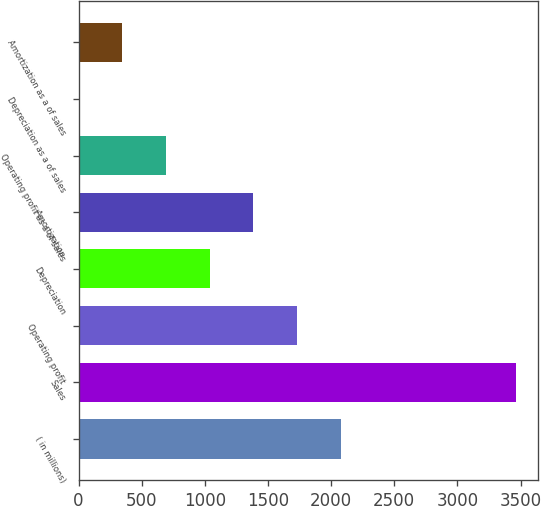<chart> <loc_0><loc_0><loc_500><loc_500><bar_chart><fcel>( in millions)<fcel>Sales<fcel>Operating profit<fcel>Depreciation<fcel>Amortization<fcel>Operating profit as a of sales<fcel>Depreciation as a of sales<fcel>Amortization as a of sales<nl><fcel>2077.62<fcel>3461.9<fcel>1731.55<fcel>1039.41<fcel>1385.48<fcel>693.34<fcel>1.2<fcel>347.27<nl></chart> 